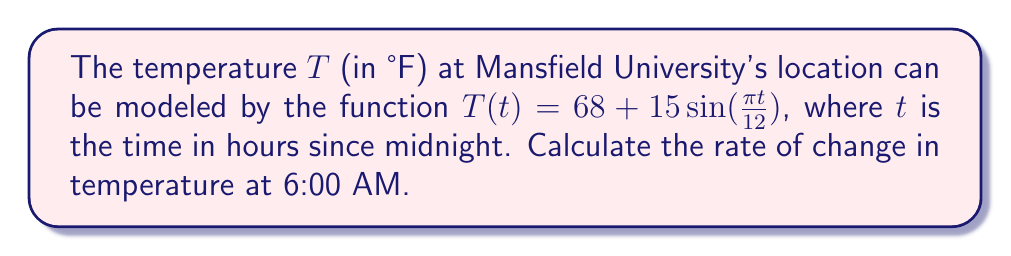Could you help me with this problem? To find the rate of change in temperature at 6:00 AM, we need to calculate the derivative of the temperature function $T(t)$ and evaluate it at $t = 6$.

1. Given function: $T(t) = 68 + 15\sin(\frac{\pi t}{12})$

2. Calculate the derivative $T'(t)$ using the chain rule:
   $$T'(t) = 15 \cdot \cos(\frac{\pi t}{12}) \cdot \frac{\pi}{12}$$
   $$T'(t) = \frac{5\pi}{4} \cos(\frac{\pi t}{12})$$

3. Evaluate $T'(t)$ at $t = 6$ (6:00 AM):
   $$T'(6) = \frac{5\pi}{4} \cos(\frac{\pi \cdot 6}{12})$$
   $$T'(6) = \frac{5\pi}{4} \cos(\frac{\pi}{2})$$

4. Recall that $\cos(\frac{\pi}{2}) = 0$:
   $$T'(6) = \frac{5\pi}{4} \cdot 0 = 0$$

Therefore, the rate of change in temperature at 6:00 AM is 0°F per hour.
Answer: 0°F/hr 